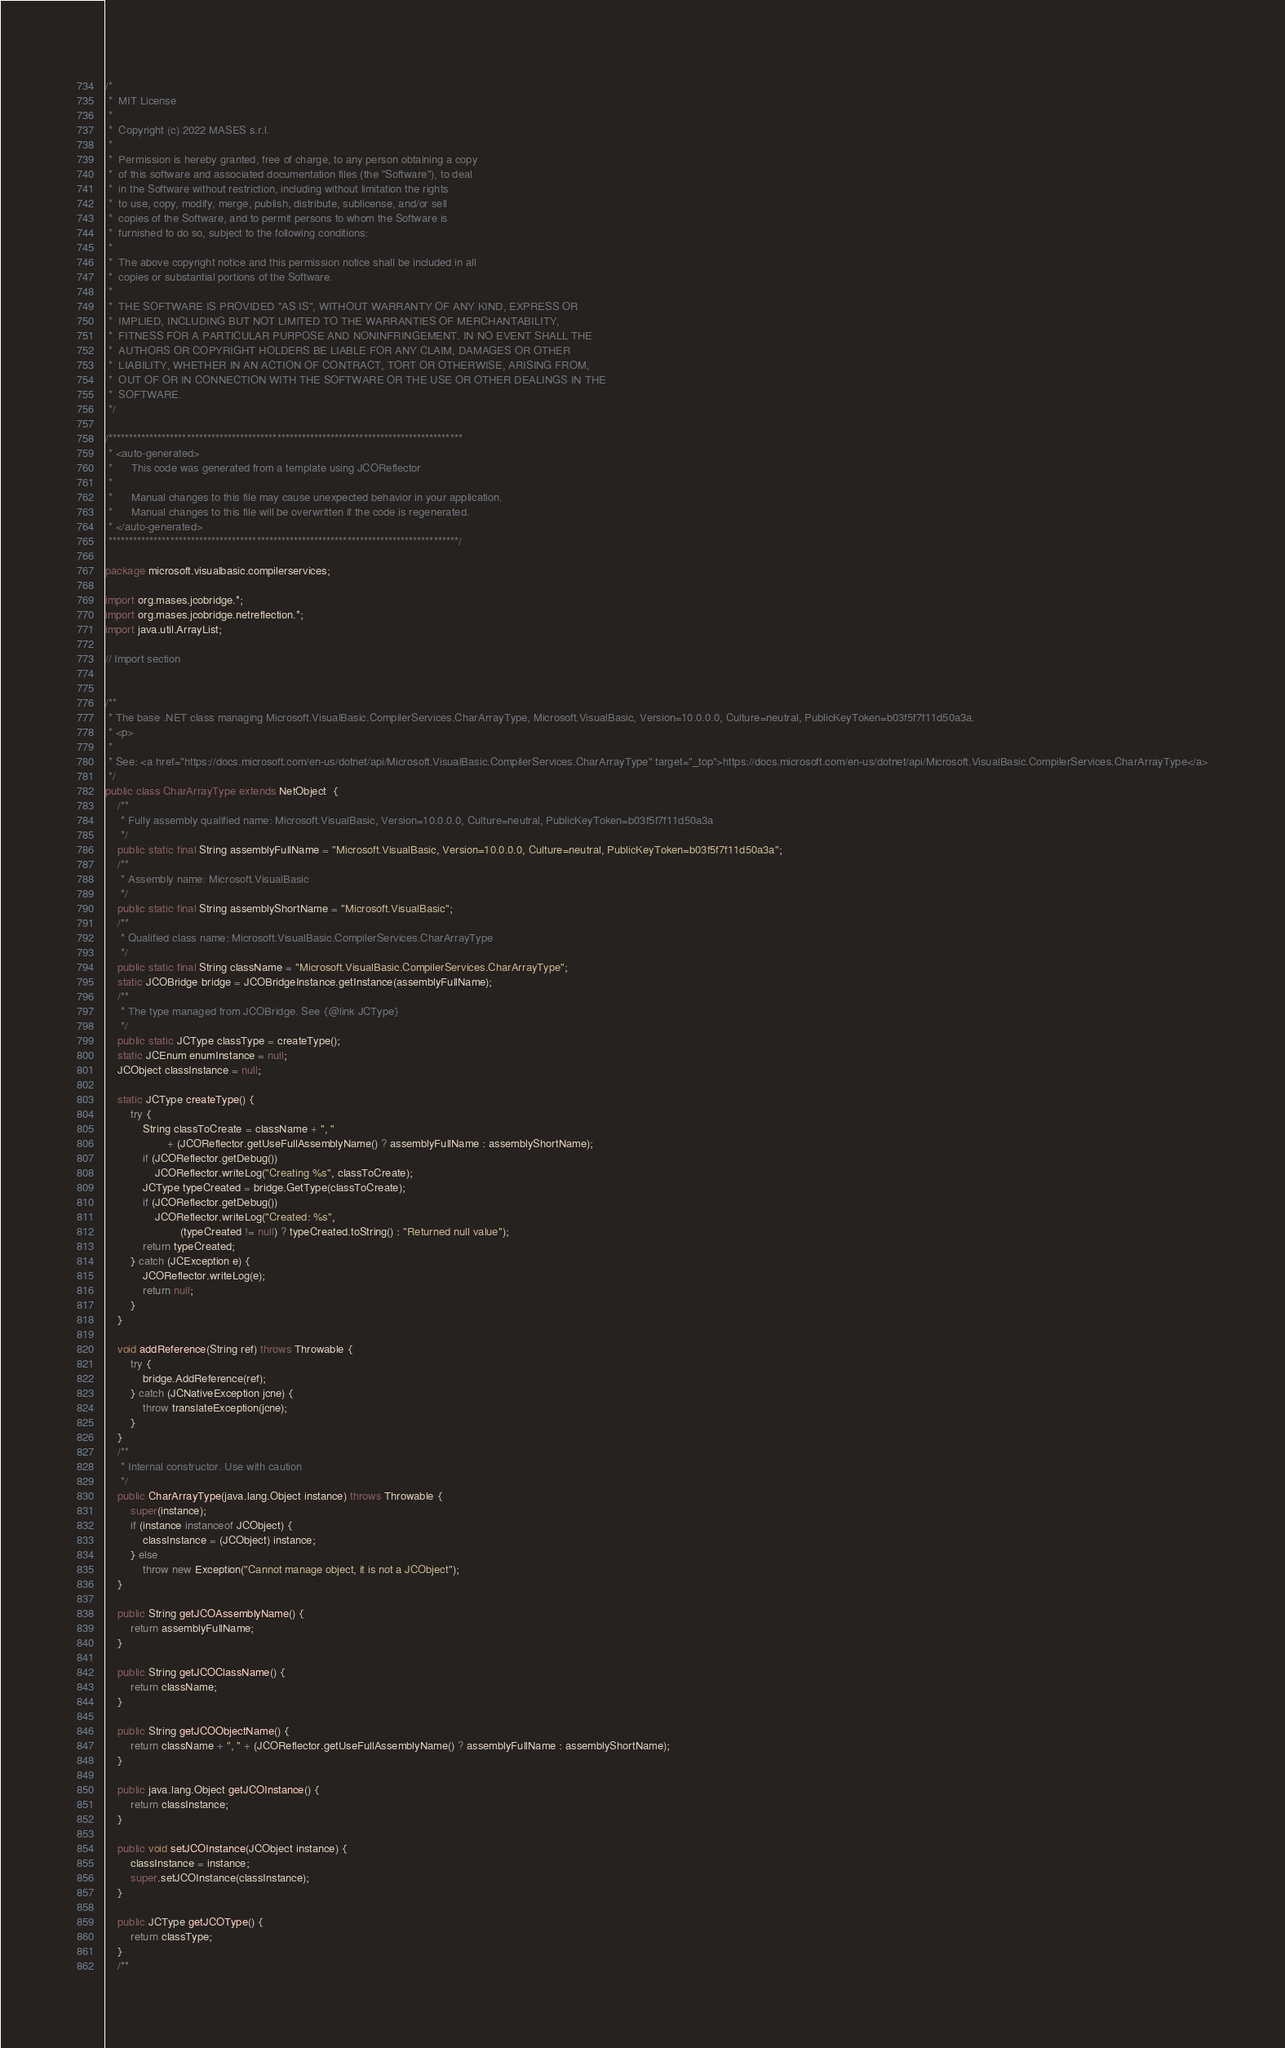<code> <loc_0><loc_0><loc_500><loc_500><_Java_>/*
 *  MIT License
 *
 *  Copyright (c) 2022 MASES s.r.l.
 *
 *  Permission is hereby granted, free of charge, to any person obtaining a copy
 *  of this software and associated documentation files (the "Software"), to deal
 *  in the Software without restriction, including without limitation the rights
 *  to use, copy, modify, merge, publish, distribute, sublicense, and/or sell
 *  copies of the Software, and to permit persons to whom the Software is
 *  furnished to do so, subject to the following conditions:
 *
 *  The above copyright notice and this permission notice shall be included in all
 *  copies or substantial portions of the Software.
 *
 *  THE SOFTWARE IS PROVIDED "AS IS", WITHOUT WARRANTY OF ANY KIND, EXPRESS OR
 *  IMPLIED, INCLUDING BUT NOT LIMITED TO THE WARRANTIES OF MERCHANTABILITY,
 *  FITNESS FOR A PARTICULAR PURPOSE AND NONINFRINGEMENT. IN NO EVENT SHALL THE
 *  AUTHORS OR COPYRIGHT HOLDERS BE LIABLE FOR ANY CLAIM, DAMAGES OR OTHER
 *  LIABILITY, WHETHER IN AN ACTION OF CONTRACT, TORT OR OTHERWISE, ARISING FROM,
 *  OUT OF OR IN CONNECTION WITH THE SOFTWARE OR THE USE OR OTHER DEALINGS IN THE
 *  SOFTWARE.
 */

/**************************************************************************************
 * <auto-generated>
 *      This code was generated from a template using JCOReflector
 * 
 *      Manual changes to this file may cause unexpected behavior in your application.
 *      Manual changes to this file will be overwritten if the code is regenerated.
 * </auto-generated>
 *************************************************************************************/

package microsoft.visualbasic.compilerservices;

import org.mases.jcobridge.*;
import org.mases.jcobridge.netreflection.*;
import java.util.ArrayList;

// Import section


/**
 * The base .NET class managing Microsoft.VisualBasic.CompilerServices.CharArrayType, Microsoft.VisualBasic, Version=10.0.0.0, Culture=neutral, PublicKeyToken=b03f5f7f11d50a3a.
 * <p>
 * 
 * See: <a href="https://docs.microsoft.com/en-us/dotnet/api/Microsoft.VisualBasic.CompilerServices.CharArrayType" target="_top">https://docs.microsoft.com/en-us/dotnet/api/Microsoft.VisualBasic.CompilerServices.CharArrayType</a>
 */
public class CharArrayType extends NetObject  {
    /**
     * Fully assembly qualified name: Microsoft.VisualBasic, Version=10.0.0.0, Culture=neutral, PublicKeyToken=b03f5f7f11d50a3a
     */
    public static final String assemblyFullName = "Microsoft.VisualBasic, Version=10.0.0.0, Culture=neutral, PublicKeyToken=b03f5f7f11d50a3a";
    /**
     * Assembly name: Microsoft.VisualBasic
     */
    public static final String assemblyShortName = "Microsoft.VisualBasic";
    /**
     * Qualified class name: Microsoft.VisualBasic.CompilerServices.CharArrayType
     */
    public static final String className = "Microsoft.VisualBasic.CompilerServices.CharArrayType";
    static JCOBridge bridge = JCOBridgeInstance.getInstance(assemblyFullName);
    /**
     * The type managed from JCOBridge. See {@link JCType}
     */
    public static JCType classType = createType();
    static JCEnum enumInstance = null;
    JCObject classInstance = null;

    static JCType createType() {
        try {
            String classToCreate = className + ", "
                    + (JCOReflector.getUseFullAssemblyName() ? assemblyFullName : assemblyShortName);
            if (JCOReflector.getDebug())
                JCOReflector.writeLog("Creating %s", classToCreate);
            JCType typeCreated = bridge.GetType(classToCreate);
            if (JCOReflector.getDebug())
                JCOReflector.writeLog("Created: %s",
                        (typeCreated != null) ? typeCreated.toString() : "Returned null value");
            return typeCreated;
        } catch (JCException e) {
            JCOReflector.writeLog(e);
            return null;
        }
    }

    void addReference(String ref) throws Throwable {
        try {
            bridge.AddReference(ref);
        } catch (JCNativeException jcne) {
            throw translateException(jcne);
        }
    }
    /**
     * Internal constructor. Use with caution 
     */
    public CharArrayType(java.lang.Object instance) throws Throwable {
        super(instance);
        if (instance instanceof JCObject) {
            classInstance = (JCObject) instance;
        } else
            throw new Exception("Cannot manage object, it is not a JCObject");
    }

    public String getJCOAssemblyName() {
        return assemblyFullName;
    }

    public String getJCOClassName() {
        return className;
    }

    public String getJCOObjectName() {
        return className + ", " + (JCOReflector.getUseFullAssemblyName() ? assemblyFullName : assemblyShortName);
    }

    public java.lang.Object getJCOInstance() {
        return classInstance;
    }

    public void setJCOInstance(JCObject instance) {
        classInstance = instance;
        super.setJCOInstance(classInstance);
    }

    public JCType getJCOType() {
        return classType;
    }
    /**</code> 